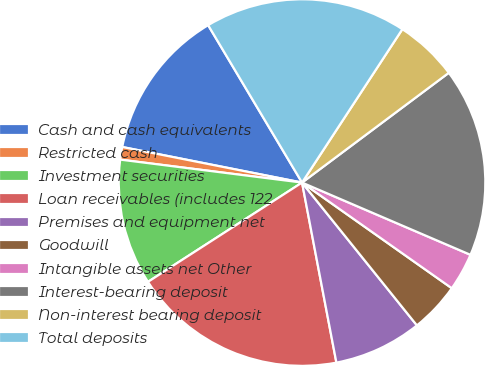Convert chart. <chart><loc_0><loc_0><loc_500><loc_500><pie_chart><fcel>Cash and cash equivalents<fcel>Restricted cash<fcel>Investment securities<fcel>Loan receivables (includes 122<fcel>Premises and equipment net<fcel>Goodwill<fcel>Intangible assets net Other<fcel>Interest-bearing deposit<fcel>Non-interest bearing deposit<fcel>Total deposits<nl><fcel>13.33%<fcel>1.11%<fcel>11.11%<fcel>18.89%<fcel>7.78%<fcel>4.44%<fcel>3.33%<fcel>16.67%<fcel>5.56%<fcel>17.78%<nl></chart> 